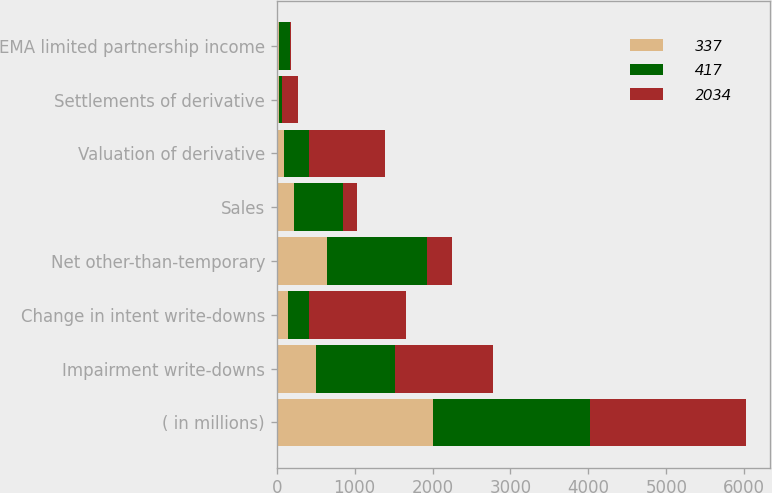Convert chart. <chart><loc_0><loc_0><loc_500><loc_500><stacked_bar_chart><ecel><fcel>( in millions)<fcel>Impairment write-downs<fcel>Change in intent write-downs<fcel>Net other-than-temporary<fcel>Sales<fcel>Valuation of derivative<fcel>Settlements of derivative<fcel>EMA limited partnership income<nl><fcel>337<fcel>2010<fcel>501<fcel>142<fcel>643<fcel>219<fcel>94<fcel>31<fcel>32<nl><fcel>417<fcel>2009<fcel>1021<fcel>268<fcel>1289<fcel>638<fcel>315<fcel>41<fcel>136<nl><fcel>2034<fcel>2008<fcel>1256<fcel>1247<fcel>315<fcel>178<fcel>985<fcel>197<fcel>14<nl></chart> 